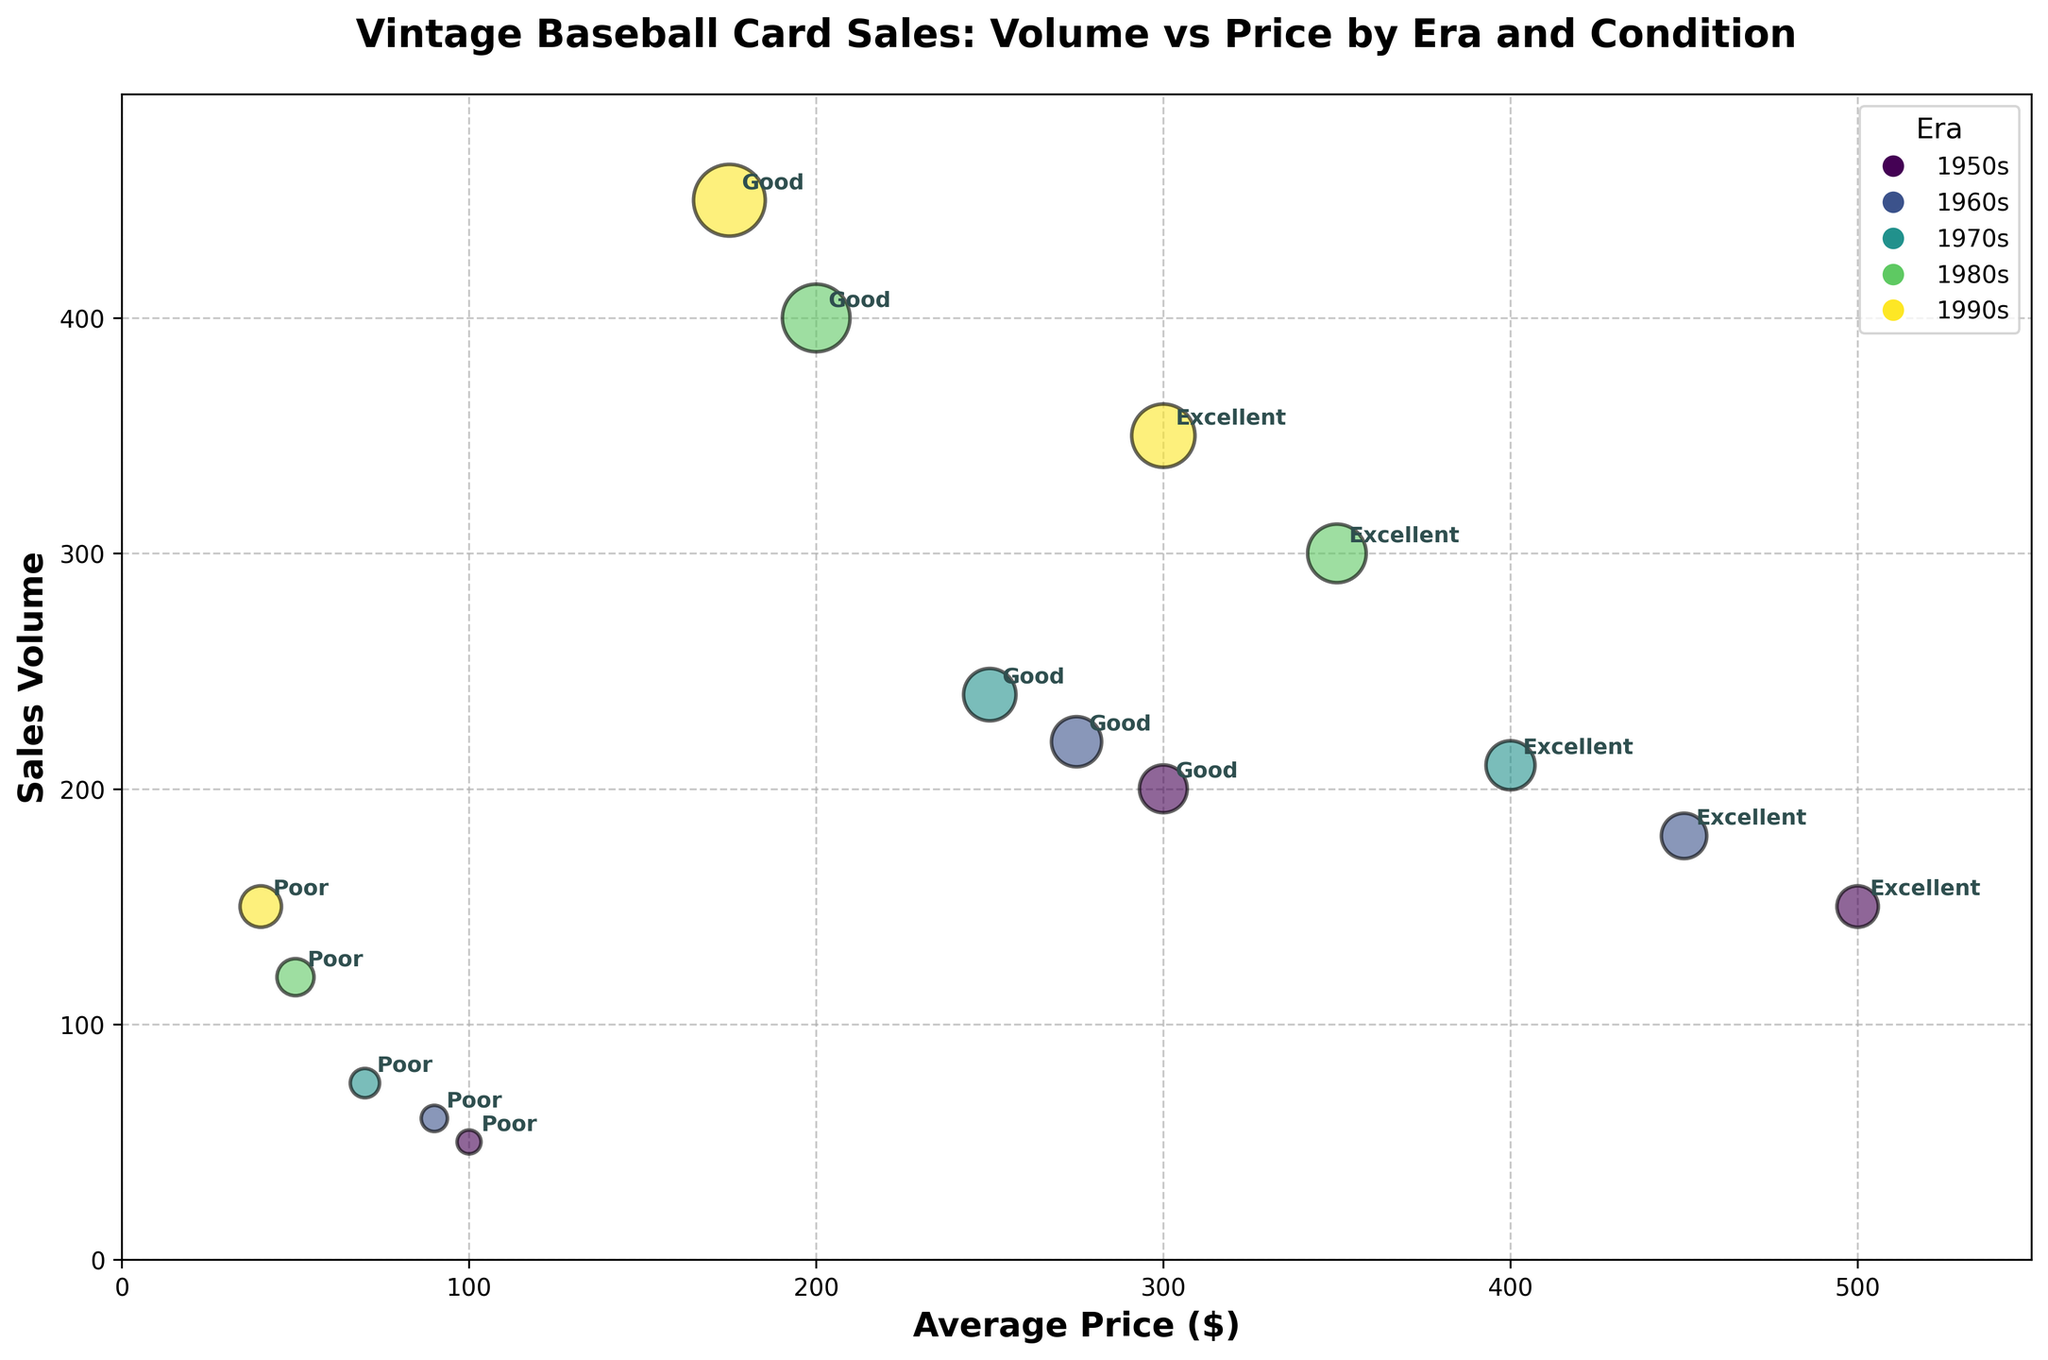Which Era has the highest average price for Excellent condition cards? Look at the data points under the "Excellent" condition category. The highest average price for Excellent condition cards is in the 1950s at $500.
Answer: 1950s What is the overall title of the chart? The title of the chart is displayed prominently at the top of the figure. It reads "Vintage Baseball Card Sales: Volume vs Price by Era and Condition."
Answer: Vintage Baseball Card Sales: Volume vs Price by Era and Condition How many distinct eras are represented in the chart? The legend shows distinct colors representing different eras. By counting the legends, we can see there are 5 distinct eras.
Answer: 5 Which card condition for the 1980s has the highest sales volume? For the 1980s, compare the sales volume of Excellent, Good, and Poor conditions. The Good condition has the highest sales volume at 400.
Answer: Good What is the total sales volume of cards in Poor condition from all eras combined? Sum the sales volumes for Poor condition cards from each era: 50 (1950s) + 60 (1960s) + 75 (1970s) + 120 (1980s) + 150 (1990s) = 455.
Answer: 455 For which era do Good condition cards have a higher sales volume than the Excellent condition cards? Compare the sales volume of Good and Excellent conditions for each era. In the 1990s, cards in Good condition (450) have a higher volume than Excellent condition (350).
Answer: 1990s What is the difference in average price between Excellent condition cards from the 1950s and 1990s? Subtract the average price for Excellent condition cards of the 1990s ($300) from that of the 1950s ($500). The difference is $500 - $300 = $200.
Answer: $200 Which era's Poor condition cards have the lowest average price? Compare the average prices for Poor condition cards across all eras. The 1990s have the lowest average price at $40.
Answer: 1990s How does the sales volume of Good condition cards in the 1970s compare to Excellent condition cards in the same era? Compare the sales volume figures: Good condition in the 1970s has a sales volume of 240, which is higher than the 210 for Excellent condition in the same era.
Answer: Higher For which card condition is the difference between the highest and lowest average price the largest? Calculate the range (difference between highest and lowest) for average prices in Excellent, Good, and Poor conditions. Excellent: $500 (1950s) - $300 (1990s) = $200, Good: $300 (1950s) - $175 (1990s) = $125, Poor: $100 (1950s) - $40 (1990s) = $60. Excellent has the largest difference.
Answer: Excellent 